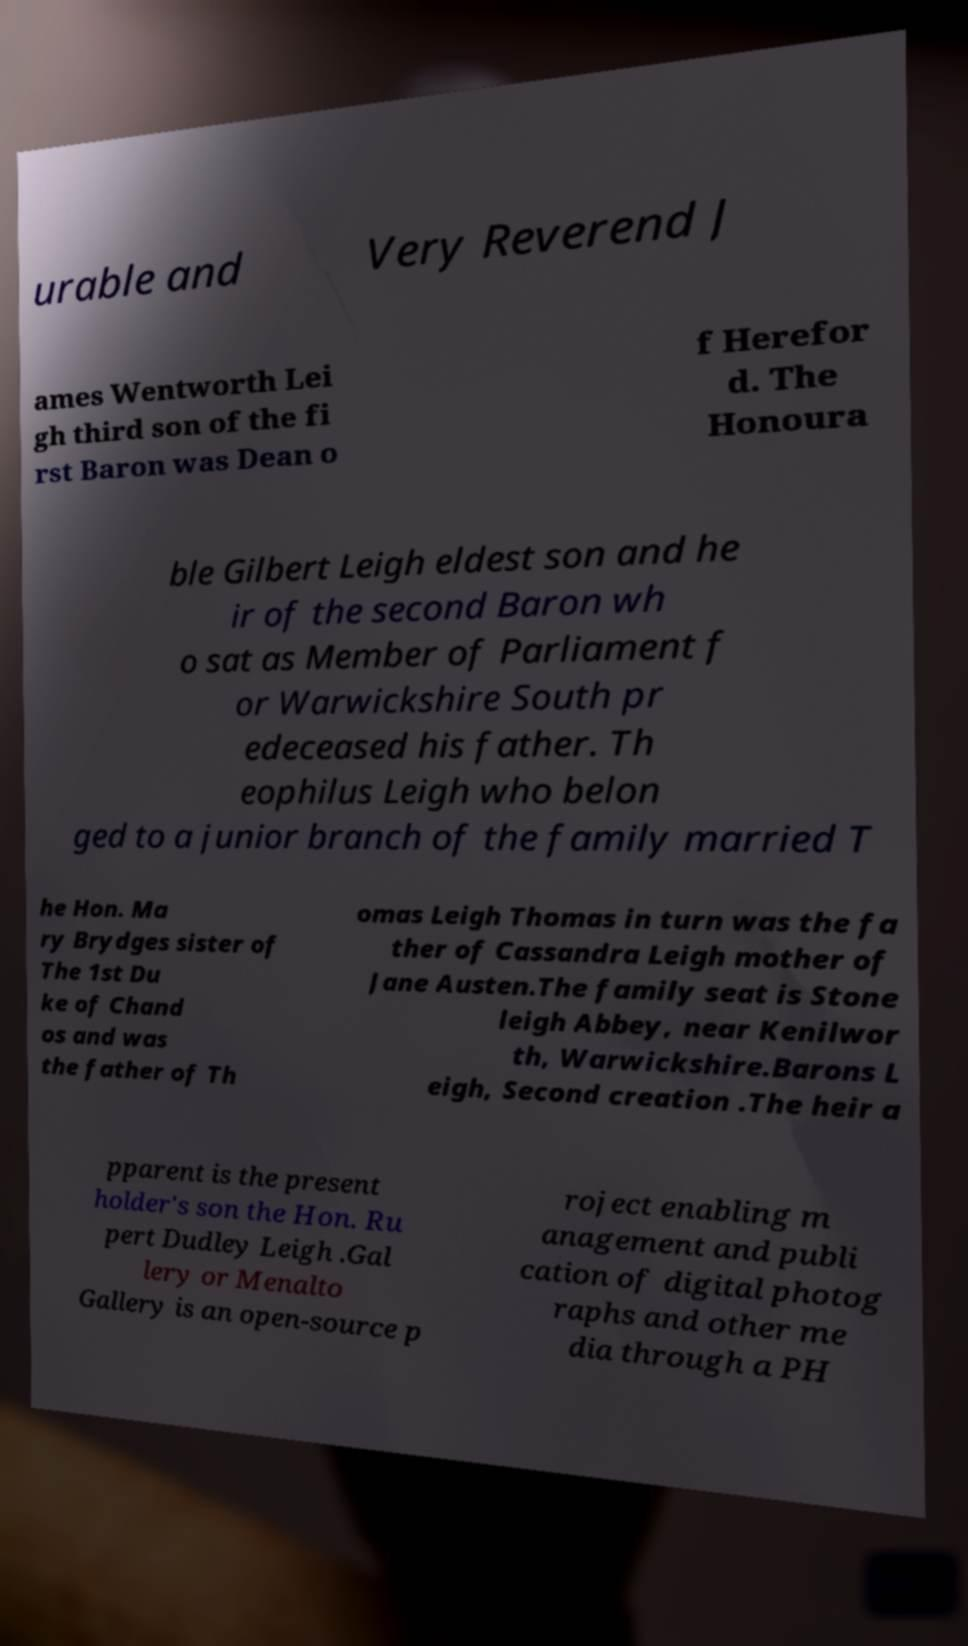Can you read and provide the text displayed in the image?This photo seems to have some interesting text. Can you extract and type it out for me? urable and Very Reverend J ames Wentworth Lei gh third son of the fi rst Baron was Dean o f Herefor d. The Honoura ble Gilbert Leigh eldest son and he ir of the second Baron wh o sat as Member of Parliament f or Warwickshire South pr edeceased his father. Th eophilus Leigh who belon ged to a junior branch of the family married T he Hon. Ma ry Brydges sister of The 1st Du ke of Chand os and was the father of Th omas Leigh Thomas in turn was the fa ther of Cassandra Leigh mother of Jane Austen.The family seat is Stone leigh Abbey, near Kenilwor th, Warwickshire.Barons L eigh, Second creation .The heir a pparent is the present holder's son the Hon. Ru pert Dudley Leigh .Gal lery or Menalto Gallery is an open-source p roject enabling m anagement and publi cation of digital photog raphs and other me dia through a PH 